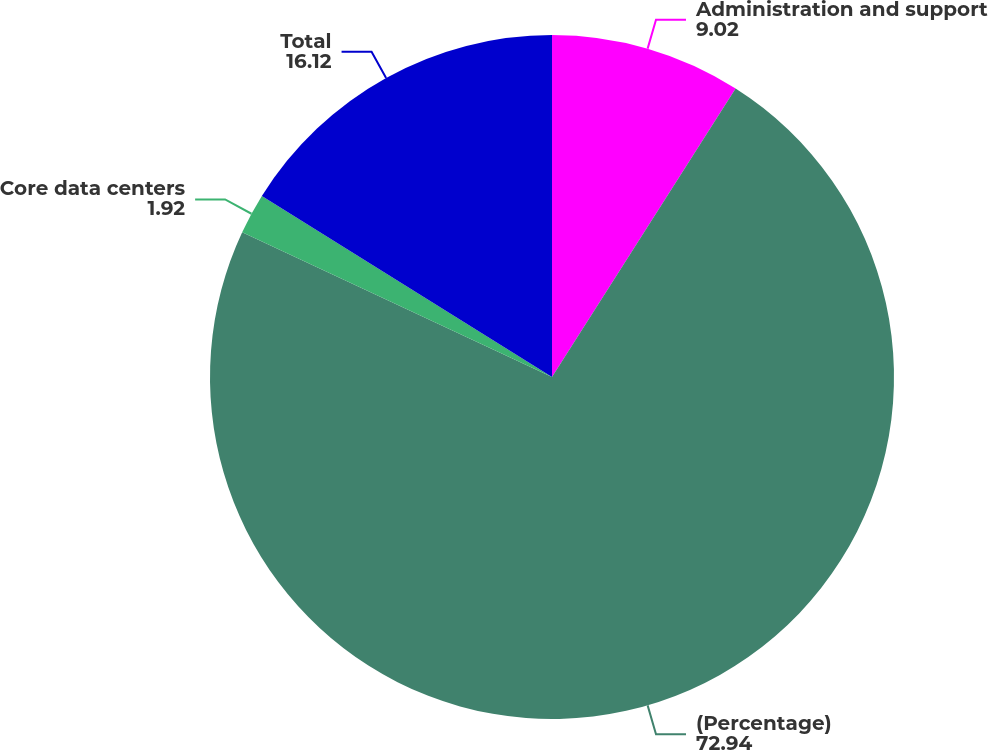<chart> <loc_0><loc_0><loc_500><loc_500><pie_chart><fcel>Administration and support<fcel>(Percentage)<fcel>Core data centers<fcel>Total<nl><fcel>9.02%<fcel>72.94%<fcel>1.92%<fcel>16.12%<nl></chart> 